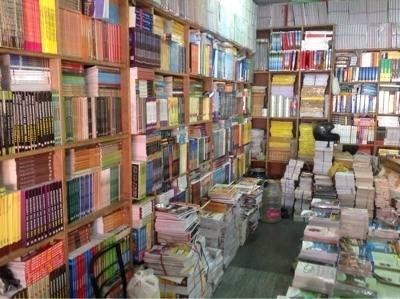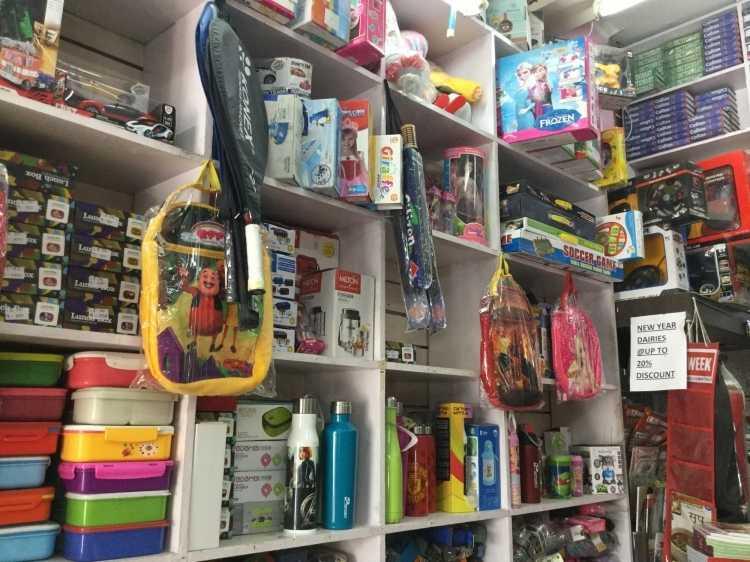The first image is the image on the left, the second image is the image on the right. Considering the images on both sides, is "There are books on a table." valid? Answer yes or no. No. The first image is the image on the left, the second image is the image on the right. Evaluate the accuracy of this statement regarding the images: "In the left image, books stacked flat are in front of books upright on rows of light-colored wood shelves, while the right image shows a variety of non-book items filling shelves on the walls.". Is it true? Answer yes or no. Yes. 